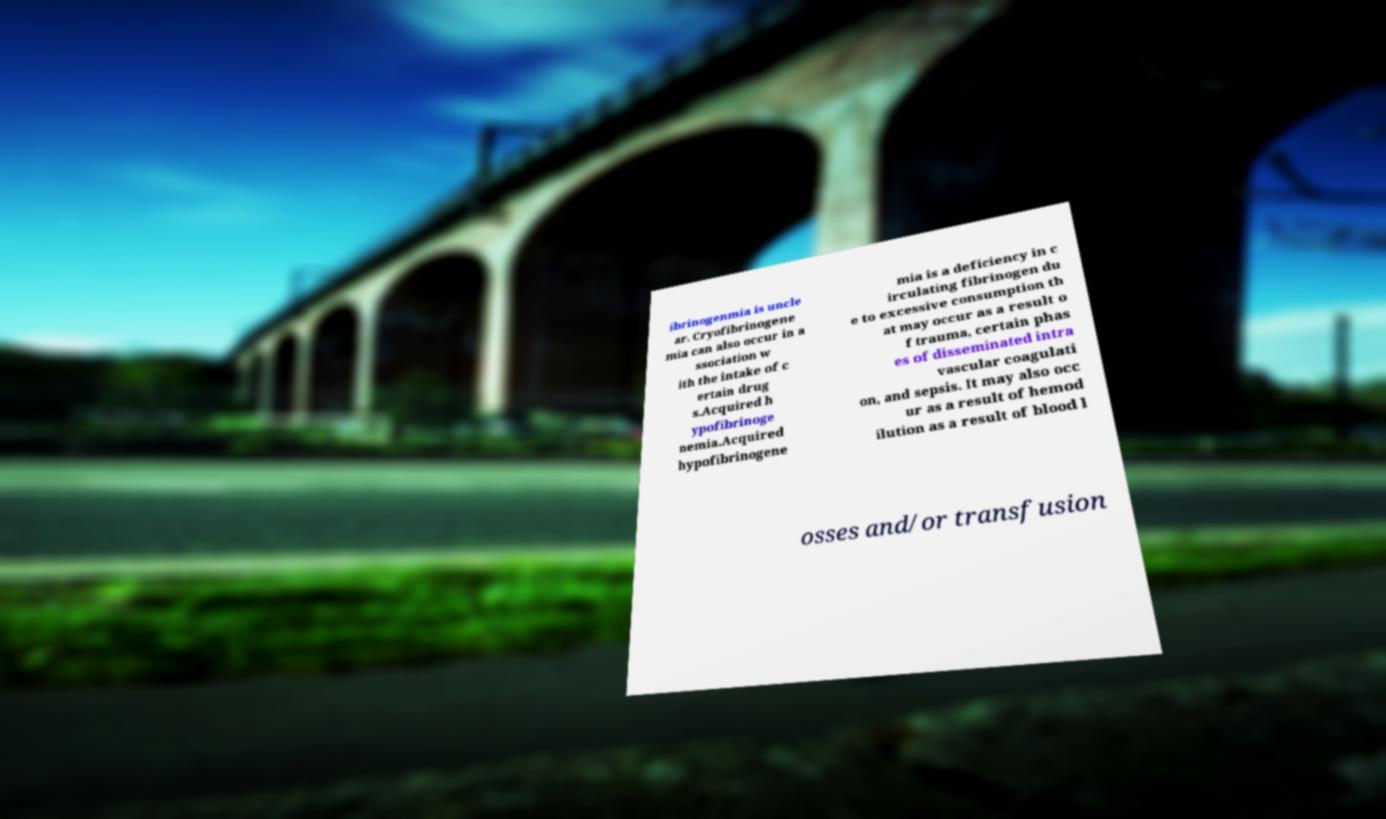Can you read and provide the text displayed in the image?This photo seems to have some interesting text. Can you extract and type it out for me? ibrinogenmia is uncle ar. Cryofibrinogene mia can also occur in a ssociation w ith the intake of c ertain drug s.Acquired h ypofibrinoge nemia.Acquired hypofibrinogene mia is a deficiency in c irculating fibrinogen du e to excessive consumption th at may occur as a result o f trauma, certain phas es of disseminated intra vascular coagulati on, and sepsis. It may also occ ur as a result of hemod ilution as a result of blood l osses and/or transfusion 